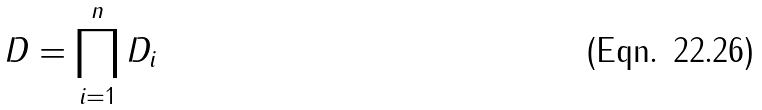<formula> <loc_0><loc_0><loc_500><loc_500>D = \prod _ { i = 1 } ^ { n } D _ { i }</formula> 